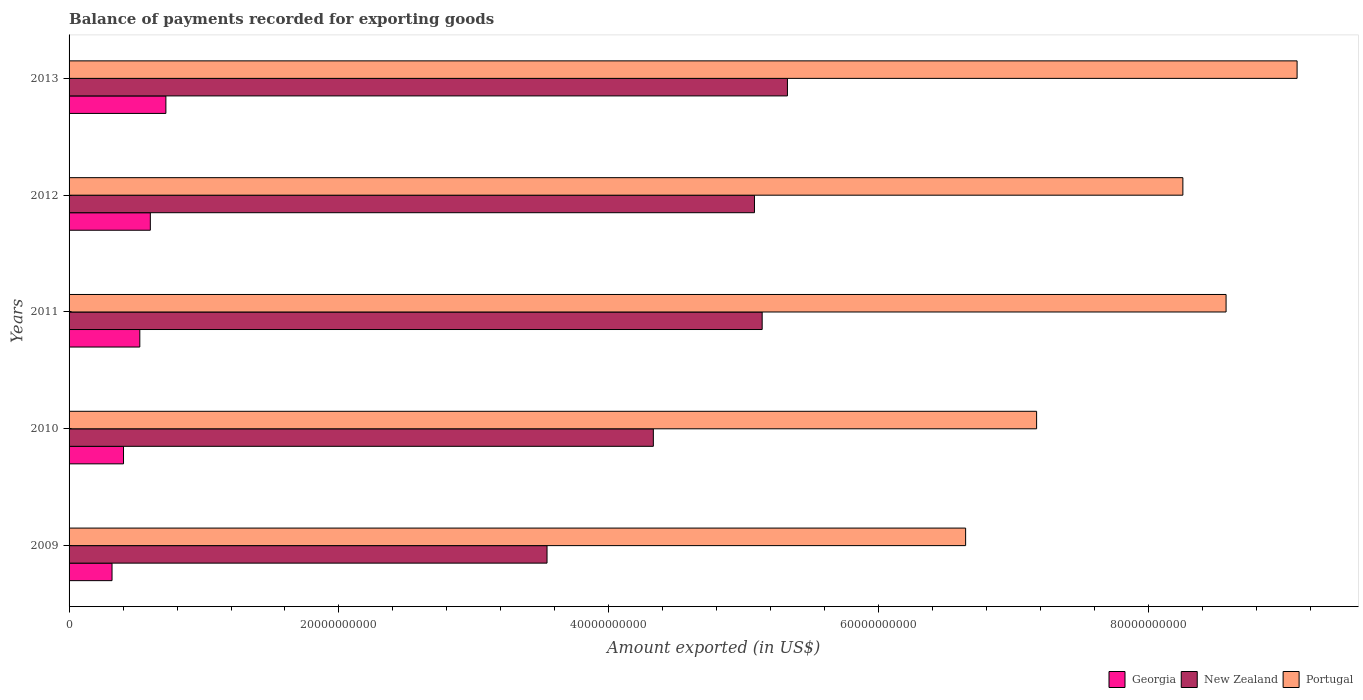How many different coloured bars are there?
Give a very brief answer. 3. Are the number of bars on each tick of the Y-axis equal?
Keep it short and to the point. Yes. What is the label of the 2nd group of bars from the top?
Make the answer very short. 2012. In how many cases, is the number of bars for a given year not equal to the number of legend labels?
Make the answer very short. 0. What is the amount exported in Portugal in 2012?
Your answer should be very brief. 8.25e+1. Across all years, what is the maximum amount exported in New Zealand?
Make the answer very short. 5.32e+1. Across all years, what is the minimum amount exported in Portugal?
Offer a terse response. 6.64e+1. In which year was the amount exported in New Zealand maximum?
Provide a succinct answer. 2013. What is the total amount exported in Georgia in the graph?
Make the answer very short. 2.57e+1. What is the difference between the amount exported in Portugal in 2009 and that in 2011?
Keep it short and to the point. -1.93e+1. What is the difference between the amount exported in New Zealand in 2010 and the amount exported in Portugal in 2009?
Ensure brevity in your answer.  -2.31e+1. What is the average amount exported in New Zealand per year?
Your answer should be very brief. 4.68e+1. In the year 2011, what is the difference between the amount exported in New Zealand and amount exported in Portugal?
Provide a short and direct response. -3.44e+1. What is the ratio of the amount exported in Portugal in 2010 to that in 2013?
Your answer should be very brief. 0.79. What is the difference between the highest and the second highest amount exported in Portugal?
Provide a succinct answer. 5.26e+09. What is the difference between the highest and the lowest amount exported in Portugal?
Give a very brief answer. 2.46e+1. In how many years, is the amount exported in New Zealand greater than the average amount exported in New Zealand taken over all years?
Your answer should be compact. 3. What does the 3rd bar from the top in 2009 represents?
Your response must be concise. Georgia. What does the 2nd bar from the bottom in 2010 represents?
Your response must be concise. New Zealand. Is it the case that in every year, the sum of the amount exported in New Zealand and amount exported in Portugal is greater than the amount exported in Georgia?
Your response must be concise. Yes. How many years are there in the graph?
Offer a terse response. 5. What is the difference between two consecutive major ticks on the X-axis?
Provide a succinct answer. 2.00e+1. Where does the legend appear in the graph?
Your answer should be compact. Bottom right. How many legend labels are there?
Give a very brief answer. 3. How are the legend labels stacked?
Ensure brevity in your answer.  Horizontal. What is the title of the graph?
Your answer should be very brief. Balance of payments recorded for exporting goods. Does "Netherlands" appear as one of the legend labels in the graph?
Ensure brevity in your answer.  No. What is the label or title of the X-axis?
Ensure brevity in your answer.  Amount exported (in US$). What is the Amount exported (in US$) in Georgia in 2009?
Provide a succinct answer. 3.18e+09. What is the Amount exported (in US$) in New Zealand in 2009?
Offer a very short reply. 3.54e+1. What is the Amount exported (in US$) of Portugal in 2009?
Your answer should be compact. 6.64e+1. What is the Amount exported (in US$) of Georgia in 2010?
Make the answer very short. 4.03e+09. What is the Amount exported (in US$) of New Zealand in 2010?
Make the answer very short. 4.33e+1. What is the Amount exported (in US$) in Portugal in 2010?
Provide a short and direct response. 7.17e+1. What is the Amount exported (in US$) in Georgia in 2011?
Your answer should be compact. 5.24e+09. What is the Amount exported (in US$) of New Zealand in 2011?
Your answer should be compact. 5.14e+1. What is the Amount exported (in US$) in Portugal in 2011?
Your answer should be compact. 8.57e+1. What is the Amount exported (in US$) in Georgia in 2012?
Your answer should be very brief. 6.02e+09. What is the Amount exported (in US$) in New Zealand in 2012?
Provide a succinct answer. 5.08e+1. What is the Amount exported (in US$) in Portugal in 2012?
Ensure brevity in your answer.  8.25e+1. What is the Amount exported (in US$) of Georgia in 2013?
Offer a terse response. 7.17e+09. What is the Amount exported (in US$) of New Zealand in 2013?
Make the answer very short. 5.32e+1. What is the Amount exported (in US$) of Portugal in 2013?
Provide a short and direct response. 9.10e+1. Across all years, what is the maximum Amount exported (in US$) in Georgia?
Give a very brief answer. 7.17e+09. Across all years, what is the maximum Amount exported (in US$) in New Zealand?
Your answer should be very brief. 5.32e+1. Across all years, what is the maximum Amount exported (in US$) in Portugal?
Provide a succinct answer. 9.10e+1. Across all years, what is the minimum Amount exported (in US$) in Georgia?
Provide a succinct answer. 3.18e+09. Across all years, what is the minimum Amount exported (in US$) of New Zealand?
Provide a short and direct response. 3.54e+1. Across all years, what is the minimum Amount exported (in US$) of Portugal?
Your response must be concise. 6.64e+1. What is the total Amount exported (in US$) of Georgia in the graph?
Your response must be concise. 2.57e+1. What is the total Amount exported (in US$) of New Zealand in the graph?
Offer a terse response. 2.34e+11. What is the total Amount exported (in US$) in Portugal in the graph?
Your answer should be very brief. 3.97e+11. What is the difference between the Amount exported (in US$) in Georgia in 2009 and that in 2010?
Provide a short and direct response. -8.51e+08. What is the difference between the Amount exported (in US$) of New Zealand in 2009 and that in 2010?
Offer a terse response. -7.88e+09. What is the difference between the Amount exported (in US$) of Portugal in 2009 and that in 2010?
Provide a succinct answer. -5.26e+09. What is the difference between the Amount exported (in US$) of Georgia in 2009 and that in 2011?
Your answer should be very brief. -2.06e+09. What is the difference between the Amount exported (in US$) in New Zealand in 2009 and that in 2011?
Keep it short and to the point. -1.59e+1. What is the difference between the Amount exported (in US$) of Portugal in 2009 and that in 2011?
Offer a very short reply. -1.93e+1. What is the difference between the Amount exported (in US$) of Georgia in 2009 and that in 2012?
Provide a short and direct response. -2.84e+09. What is the difference between the Amount exported (in US$) in New Zealand in 2009 and that in 2012?
Offer a terse response. -1.54e+1. What is the difference between the Amount exported (in US$) in Portugal in 2009 and that in 2012?
Provide a short and direct response. -1.61e+1. What is the difference between the Amount exported (in US$) of Georgia in 2009 and that in 2013?
Provide a short and direct response. -3.99e+09. What is the difference between the Amount exported (in US$) in New Zealand in 2009 and that in 2013?
Make the answer very short. -1.78e+1. What is the difference between the Amount exported (in US$) in Portugal in 2009 and that in 2013?
Provide a short and direct response. -2.46e+1. What is the difference between the Amount exported (in US$) of Georgia in 2010 and that in 2011?
Give a very brief answer. -1.21e+09. What is the difference between the Amount exported (in US$) in New Zealand in 2010 and that in 2011?
Your answer should be very brief. -8.06e+09. What is the difference between the Amount exported (in US$) in Portugal in 2010 and that in 2011?
Give a very brief answer. -1.40e+1. What is the difference between the Amount exported (in US$) of Georgia in 2010 and that in 2012?
Make the answer very short. -1.99e+09. What is the difference between the Amount exported (in US$) of New Zealand in 2010 and that in 2012?
Offer a terse response. -7.49e+09. What is the difference between the Amount exported (in US$) of Portugal in 2010 and that in 2012?
Provide a short and direct response. -1.08e+1. What is the difference between the Amount exported (in US$) in Georgia in 2010 and that in 2013?
Offer a very short reply. -3.14e+09. What is the difference between the Amount exported (in US$) of New Zealand in 2010 and that in 2013?
Give a very brief answer. -9.94e+09. What is the difference between the Amount exported (in US$) of Portugal in 2010 and that in 2013?
Give a very brief answer. -1.93e+1. What is the difference between the Amount exported (in US$) of Georgia in 2011 and that in 2012?
Ensure brevity in your answer.  -7.79e+08. What is the difference between the Amount exported (in US$) in New Zealand in 2011 and that in 2012?
Offer a very short reply. 5.71e+08. What is the difference between the Amount exported (in US$) of Portugal in 2011 and that in 2012?
Make the answer very short. 3.20e+09. What is the difference between the Amount exported (in US$) of Georgia in 2011 and that in 2013?
Make the answer very short. -1.93e+09. What is the difference between the Amount exported (in US$) in New Zealand in 2011 and that in 2013?
Offer a very short reply. -1.87e+09. What is the difference between the Amount exported (in US$) in Portugal in 2011 and that in 2013?
Provide a short and direct response. -5.26e+09. What is the difference between the Amount exported (in US$) in Georgia in 2012 and that in 2013?
Provide a short and direct response. -1.15e+09. What is the difference between the Amount exported (in US$) in New Zealand in 2012 and that in 2013?
Your answer should be compact. -2.44e+09. What is the difference between the Amount exported (in US$) of Portugal in 2012 and that in 2013?
Your answer should be compact. -8.46e+09. What is the difference between the Amount exported (in US$) of Georgia in 2009 and the Amount exported (in US$) of New Zealand in 2010?
Keep it short and to the point. -4.01e+1. What is the difference between the Amount exported (in US$) of Georgia in 2009 and the Amount exported (in US$) of Portugal in 2010?
Your response must be concise. -6.85e+1. What is the difference between the Amount exported (in US$) of New Zealand in 2009 and the Amount exported (in US$) of Portugal in 2010?
Ensure brevity in your answer.  -3.63e+1. What is the difference between the Amount exported (in US$) in Georgia in 2009 and the Amount exported (in US$) in New Zealand in 2011?
Provide a short and direct response. -4.82e+1. What is the difference between the Amount exported (in US$) of Georgia in 2009 and the Amount exported (in US$) of Portugal in 2011?
Give a very brief answer. -8.26e+1. What is the difference between the Amount exported (in US$) in New Zealand in 2009 and the Amount exported (in US$) in Portugal in 2011?
Your response must be concise. -5.03e+1. What is the difference between the Amount exported (in US$) of Georgia in 2009 and the Amount exported (in US$) of New Zealand in 2012?
Make the answer very short. -4.76e+1. What is the difference between the Amount exported (in US$) in Georgia in 2009 and the Amount exported (in US$) in Portugal in 2012?
Your response must be concise. -7.94e+1. What is the difference between the Amount exported (in US$) of New Zealand in 2009 and the Amount exported (in US$) of Portugal in 2012?
Ensure brevity in your answer.  -4.71e+1. What is the difference between the Amount exported (in US$) of Georgia in 2009 and the Amount exported (in US$) of New Zealand in 2013?
Make the answer very short. -5.00e+1. What is the difference between the Amount exported (in US$) in Georgia in 2009 and the Amount exported (in US$) in Portugal in 2013?
Keep it short and to the point. -8.78e+1. What is the difference between the Amount exported (in US$) in New Zealand in 2009 and the Amount exported (in US$) in Portugal in 2013?
Ensure brevity in your answer.  -5.56e+1. What is the difference between the Amount exported (in US$) in Georgia in 2010 and the Amount exported (in US$) in New Zealand in 2011?
Offer a very short reply. -4.73e+1. What is the difference between the Amount exported (in US$) of Georgia in 2010 and the Amount exported (in US$) of Portugal in 2011?
Provide a short and direct response. -8.17e+1. What is the difference between the Amount exported (in US$) of New Zealand in 2010 and the Amount exported (in US$) of Portugal in 2011?
Provide a short and direct response. -4.24e+1. What is the difference between the Amount exported (in US$) in Georgia in 2010 and the Amount exported (in US$) in New Zealand in 2012?
Give a very brief answer. -4.68e+1. What is the difference between the Amount exported (in US$) in Georgia in 2010 and the Amount exported (in US$) in Portugal in 2012?
Your answer should be very brief. -7.85e+1. What is the difference between the Amount exported (in US$) of New Zealand in 2010 and the Amount exported (in US$) of Portugal in 2012?
Your answer should be compact. -3.92e+1. What is the difference between the Amount exported (in US$) in Georgia in 2010 and the Amount exported (in US$) in New Zealand in 2013?
Keep it short and to the point. -4.92e+1. What is the difference between the Amount exported (in US$) of Georgia in 2010 and the Amount exported (in US$) of Portugal in 2013?
Offer a terse response. -8.70e+1. What is the difference between the Amount exported (in US$) in New Zealand in 2010 and the Amount exported (in US$) in Portugal in 2013?
Make the answer very short. -4.77e+1. What is the difference between the Amount exported (in US$) of Georgia in 2011 and the Amount exported (in US$) of New Zealand in 2012?
Offer a very short reply. -4.55e+1. What is the difference between the Amount exported (in US$) in Georgia in 2011 and the Amount exported (in US$) in Portugal in 2012?
Keep it short and to the point. -7.73e+1. What is the difference between the Amount exported (in US$) of New Zealand in 2011 and the Amount exported (in US$) of Portugal in 2012?
Make the answer very short. -3.12e+1. What is the difference between the Amount exported (in US$) of Georgia in 2011 and the Amount exported (in US$) of New Zealand in 2013?
Make the answer very short. -4.80e+1. What is the difference between the Amount exported (in US$) of Georgia in 2011 and the Amount exported (in US$) of Portugal in 2013?
Provide a short and direct response. -8.58e+1. What is the difference between the Amount exported (in US$) of New Zealand in 2011 and the Amount exported (in US$) of Portugal in 2013?
Provide a short and direct response. -3.96e+1. What is the difference between the Amount exported (in US$) of Georgia in 2012 and the Amount exported (in US$) of New Zealand in 2013?
Ensure brevity in your answer.  -4.72e+1. What is the difference between the Amount exported (in US$) in Georgia in 2012 and the Amount exported (in US$) in Portugal in 2013?
Offer a terse response. -8.50e+1. What is the difference between the Amount exported (in US$) of New Zealand in 2012 and the Amount exported (in US$) of Portugal in 2013?
Your answer should be compact. -4.02e+1. What is the average Amount exported (in US$) of Georgia per year?
Your answer should be very brief. 5.13e+09. What is the average Amount exported (in US$) of New Zealand per year?
Give a very brief answer. 4.68e+1. What is the average Amount exported (in US$) of Portugal per year?
Provide a succinct answer. 7.95e+1. In the year 2009, what is the difference between the Amount exported (in US$) of Georgia and Amount exported (in US$) of New Zealand?
Offer a terse response. -3.22e+1. In the year 2009, what is the difference between the Amount exported (in US$) in Georgia and Amount exported (in US$) in Portugal?
Offer a very short reply. -6.33e+1. In the year 2009, what is the difference between the Amount exported (in US$) in New Zealand and Amount exported (in US$) in Portugal?
Provide a succinct answer. -3.10e+1. In the year 2010, what is the difference between the Amount exported (in US$) of Georgia and Amount exported (in US$) of New Zealand?
Provide a short and direct response. -3.93e+1. In the year 2010, what is the difference between the Amount exported (in US$) in Georgia and Amount exported (in US$) in Portugal?
Provide a short and direct response. -6.77e+1. In the year 2010, what is the difference between the Amount exported (in US$) of New Zealand and Amount exported (in US$) of Portugal?
Give a very brief answer. -2.84e+1. In the year 2011, what is the difference between the Amount exported (in US$) in Georgia and Amount exported (in US$) in New Zealand?
Make the answer very short. -4.61e+1. In the year 2011, what is the difference between the Amount exported (in US$) of Georgia and Amount exported (in US$) of Portugal?
Make the answer very short. -8.05e+1. In the year 2011, what is the difference between the Amount exported (in US$) in New Zealand and Amount exported (in US$) in Portugal?
Make the answer very short. -3.44e+1. In the year 2012, what is the difference between the Amount exported (in US$) in Georgia and Amount exported (in US$) in New Zealand?
Provide a short and direct response. -4.48e+1. In the year 2012, what is the difference between the Amount exported (in US$) in Georgia and Amount exported (in US$) in Portugal?
Your answer should be compact. -7.65e+1. In the year 2012, what is the difference between the Amount exported (in US$) in New Zealand and Amount exported (in US$) in Portugal?
Keep it short and to the point. -3.17e+1. In the year 2013, what is the difference between the Amount exported (in US$) of Georgia and Amount exported (in US$) of New Zealand?
Your answer should be very brief. -4.61e+1. In the year 2013, what is the difference between the Amount exported (in US$) in Georgia and Amount exported (in US$) in Portugal?
Your response must be concise. -8.38e+1. In the year 2013, what is the difference between the Amount exported (in US$) in New Zealand and Amount exported (in US$) in Portugal?
Your answer should be very brief. -3.78e+1. What is the ratio of the Amount exported (in US$) of Georgia in 2009 to that in 2010?
Make the answer very short. 0.79. What is the ratio of the Amount exported (in US$) of New Zealand in 2009 to that in 2010?
Ensure brevity in your answer.  0.82. What is the ratio of the Amount exported (in US$) of Portugal in 2009 to that in 2010?
Your answer should be very brief. 0.93. What is the ratio of the Amount exported (in US$) of Georgia in 2009 to that in 2011?
Provide a short and direct response. 0.61. What is the ratio of the Amount exported (in US$) of New Zealand in 2009 to that in 2011?
Make the answer very short. 0.69. What is the ratio of the Amount exported (in US$) of Portugal in 2009 to that in 2011?
Your answer should be very brief. 0.77. What is the ratio of the Amount exported (in US$) of Georgia in 2009 to that in 2012?
Give a very brief answer. 0.53. What is the ratio of the Amount exported (in US$) of New Zealand in 2009 to that in 2012?
Offer a terse response. 0.7. What is the ratio of the Amount exported (in US$) of Portugal in 2009 to that in 2012?
Provide a short and direct response. 0.8. What is the ratio of the Amount exported (in US$) in Georgia in 2009 to that in 2013?
Offer a very short reply. 0.44. What is the ratio of the Amount exported (in US$) in New Zealand in 2009 to that in 2013?
Offer a terse response. 0.67. What is the ratio of the Amount exported (in US$) in Portugal in 2009 to that in 2013?
Provide a short and direct response. 0.73. What is the ratio of the Amount exported (in US$) of Georgia in 2010 to that in 2011?
Keep it short and to the point. 0.77. What is the ratio of the Amount exported (in US$) of New Zealand in 2010 to that in 2011?
Your response must be concise. 0.84. What is the ratio of the Amount exported (in US$) in Portugal in 2010 to that in 2011?
Offer a very short reply. 0.84. What is the ratio of the Amount exported (in US$) in Georgia in 2010 to that in 2012?
Keep it short and to the point. 0.67. What is the ratio of the Amount exported (in US$) in New Zealand in 2010 to that in 2012?
Your response must be concise. 0.85. What is the ratio of the Amount exported (in US$) in Portugal in 2010 to that in 2012?
Ensure brevity in your answer.  0.87. What is the ratio of the Amount exported (in US$) of Georgia in 2010 to that in 2013?
Offer a terse response. 0.56. What is the ratio of the Amount exported (in US$) in New Zealand in 2010 to that in 2013?
Provide a short and direct response. 0.81. What is the ratio of the Amount exported (in US$) in Portugal in 2010 to that in 2013?
Give a very brief answer. 0.79. What is the ratio of the Amount exported (in US$) in Georgia in 2011 to that in 2012?
Make the answer very short. 0.87. What is the ratio of the Amount exported (in US$) of New Zealand in 2011 to that in 2012?
Your answer should be very brief. 1.01. What is the ratio of the Amount exported (in US$) of Portugal in 2011 to that in 2012?
Offer a terse response. 1.04. What is the ratio of the Amount exported (in US$) in Georgia in 2011 to that in 2013?
Give a very brief answer. 0.73. What is the ratio of the Amount exported (in US$) in New Zealand in 2011 to that in 2013?
Make the answer very short. 0.96. What is the ratio of the Amount exported (in US$) of Portugal in 2011 to that in 2013?
Give a very brief answer. 0.94. What is the ratio of the Amount exported (in US$) of Georgia in 2012 to that in 2013?
Ensure brevity in your answer.  0.84. What is the ratio of the Amount exported (in US$) of New Zealand in 2012 to that in 2013?
Offer a terse response. 0.95. What is the ratio of the Amount exported (in US$) of Portugal in 2012 to that in 2013?
Ensure brevity in your answer.  0.91. What is the difference between the highest and the second highest Amount exported (in US$) of Georgia?
Give a very brief answer. 1.15e+09. What is the difference between the highest and the second highest Amount exported (in US$) of New Zealand?
Your response must be concise. 1.87e+09. What is the difference between the highest and the second highest Amount exported (in US$) in Portugal?
Keep it short and to the point. 5.26e+09. What is the difference between the highest and the lowest Amount exported (in US$) in Georgia?
Provide a short and direct response. 3.99e+09. What is the difference between the highest and the lowest Amount exported (in US$) in New Zealand?
Make the answer very short. 1.78e+1. What is the difference between the highest and the lowest Amount exported (in US$) in Portugal?
Keep it short and to the point. 2.46e+1. 